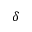Convert formula to latex. <formula><loc_0><loc_0><loc_500><loc_500>\delta</formula> 